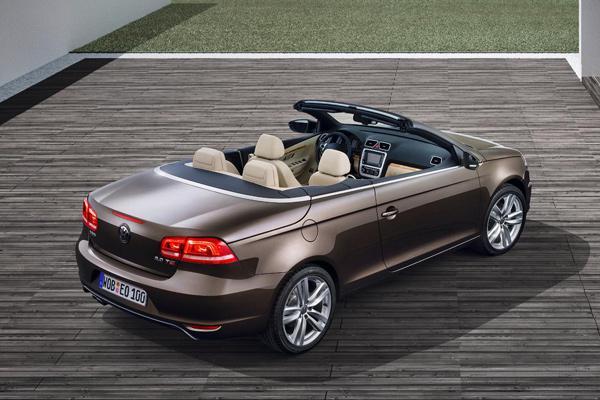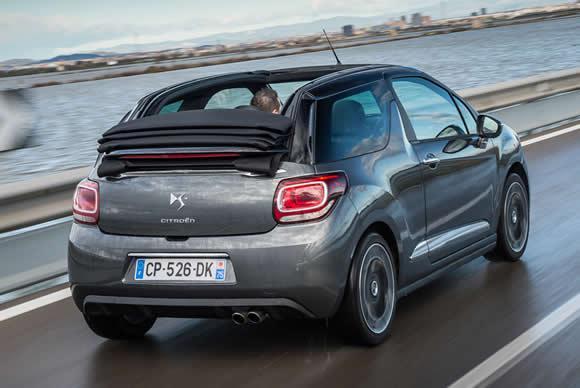The first image is the image on the left, the second image is the image on the right. For the images displayed, is the sentence "Both convertibles have their tops down." factually correct? Answer yes or no. Yes. 